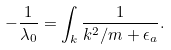<formula> <loc_0><loc_0><loc_500><loc_500>- \frac { 1 } { \lambda _ { 0 } } = \int _ { k } \frac { 1 } { { k ^ { 2 } } / m + \epsilon _ { a } } .</formula> 